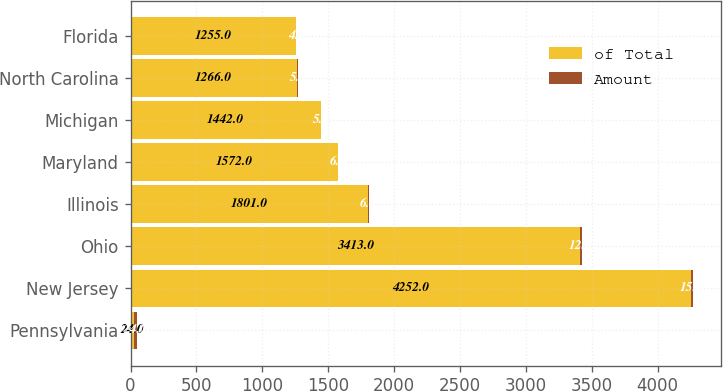Convert chart. <chart><loc_0><loc_0><loc_500><loc_500><stacked_bar_chart><ecel><fcel>Pennsylvania<fcel>New Jersey<fcel>Ohio<fcel>Illinois<fcel>Maryland<fcel>Michigan<fcel>North Carolina<fcel>Florida<nl><fcel>of Total<fcel>24<fcel>4252<fcel>3413<fcel>1801<fcel>1572<fcel>1442<fcel>1266<fcel>1255<nl><fcel>Amount<fcel>24<fcel>15<fcel>12<fcel>6<fcel>6<fcel>5<fcel>5<fcel>4<nl></chart> 